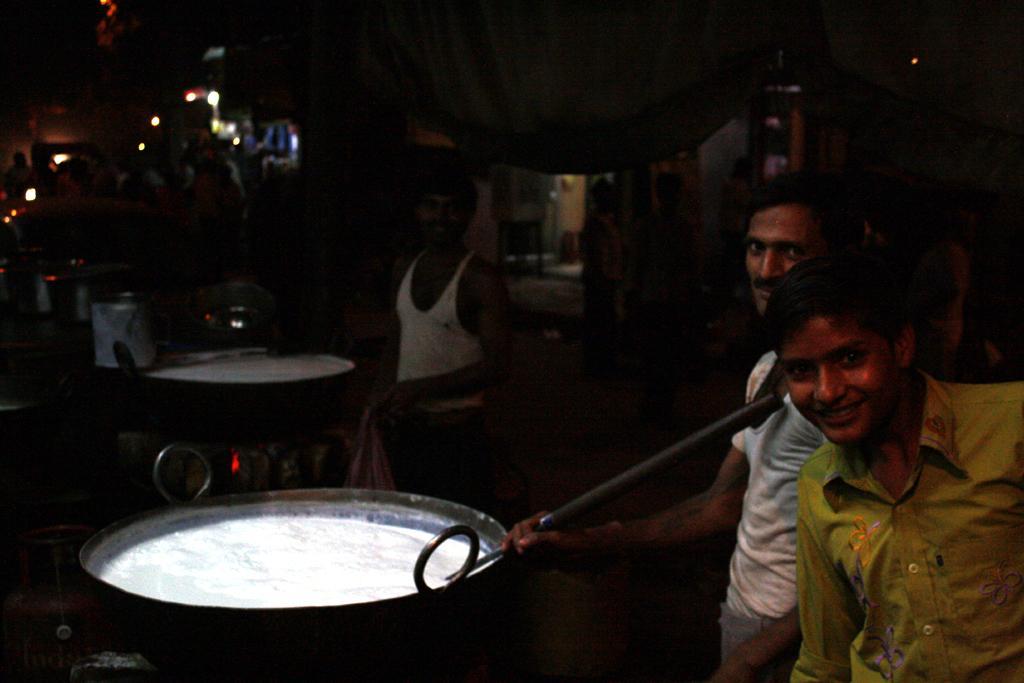How would you summarize this image in a sentence or two? In this picture we can see people, here we can see bowls, lights and some objects and in the background we can see it is dark. 